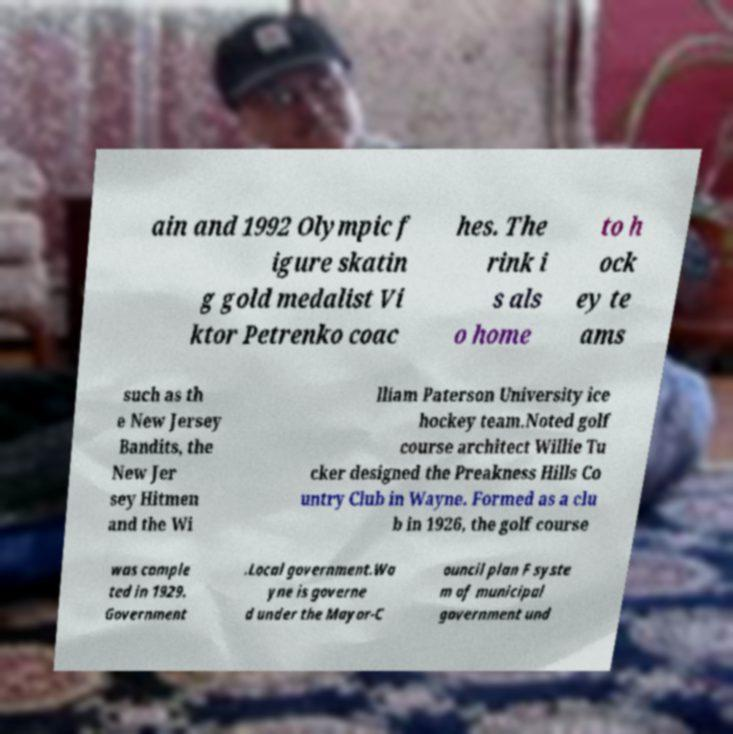Could you extract and type out the text from this image? ain and 1992 Olympic f igure skatin g gold medalist Vi ktor Petrenko coac hes. The rink i s als o home to h ock ey te ams such as th e New Jersey Bandits, the New Jer sey Hitmen and the Wi lliam Paterson University ice hockey team.Noted golf course architect Willie Tu cker designed the Preakness Hills Co untry Club in Wayne. Formed as a clu b in 1926, the golf course was comple ted in 1929. Government .Local government.Wa yne is governe d under the Mayor-C ouncil plan F syste m of municipal government und 